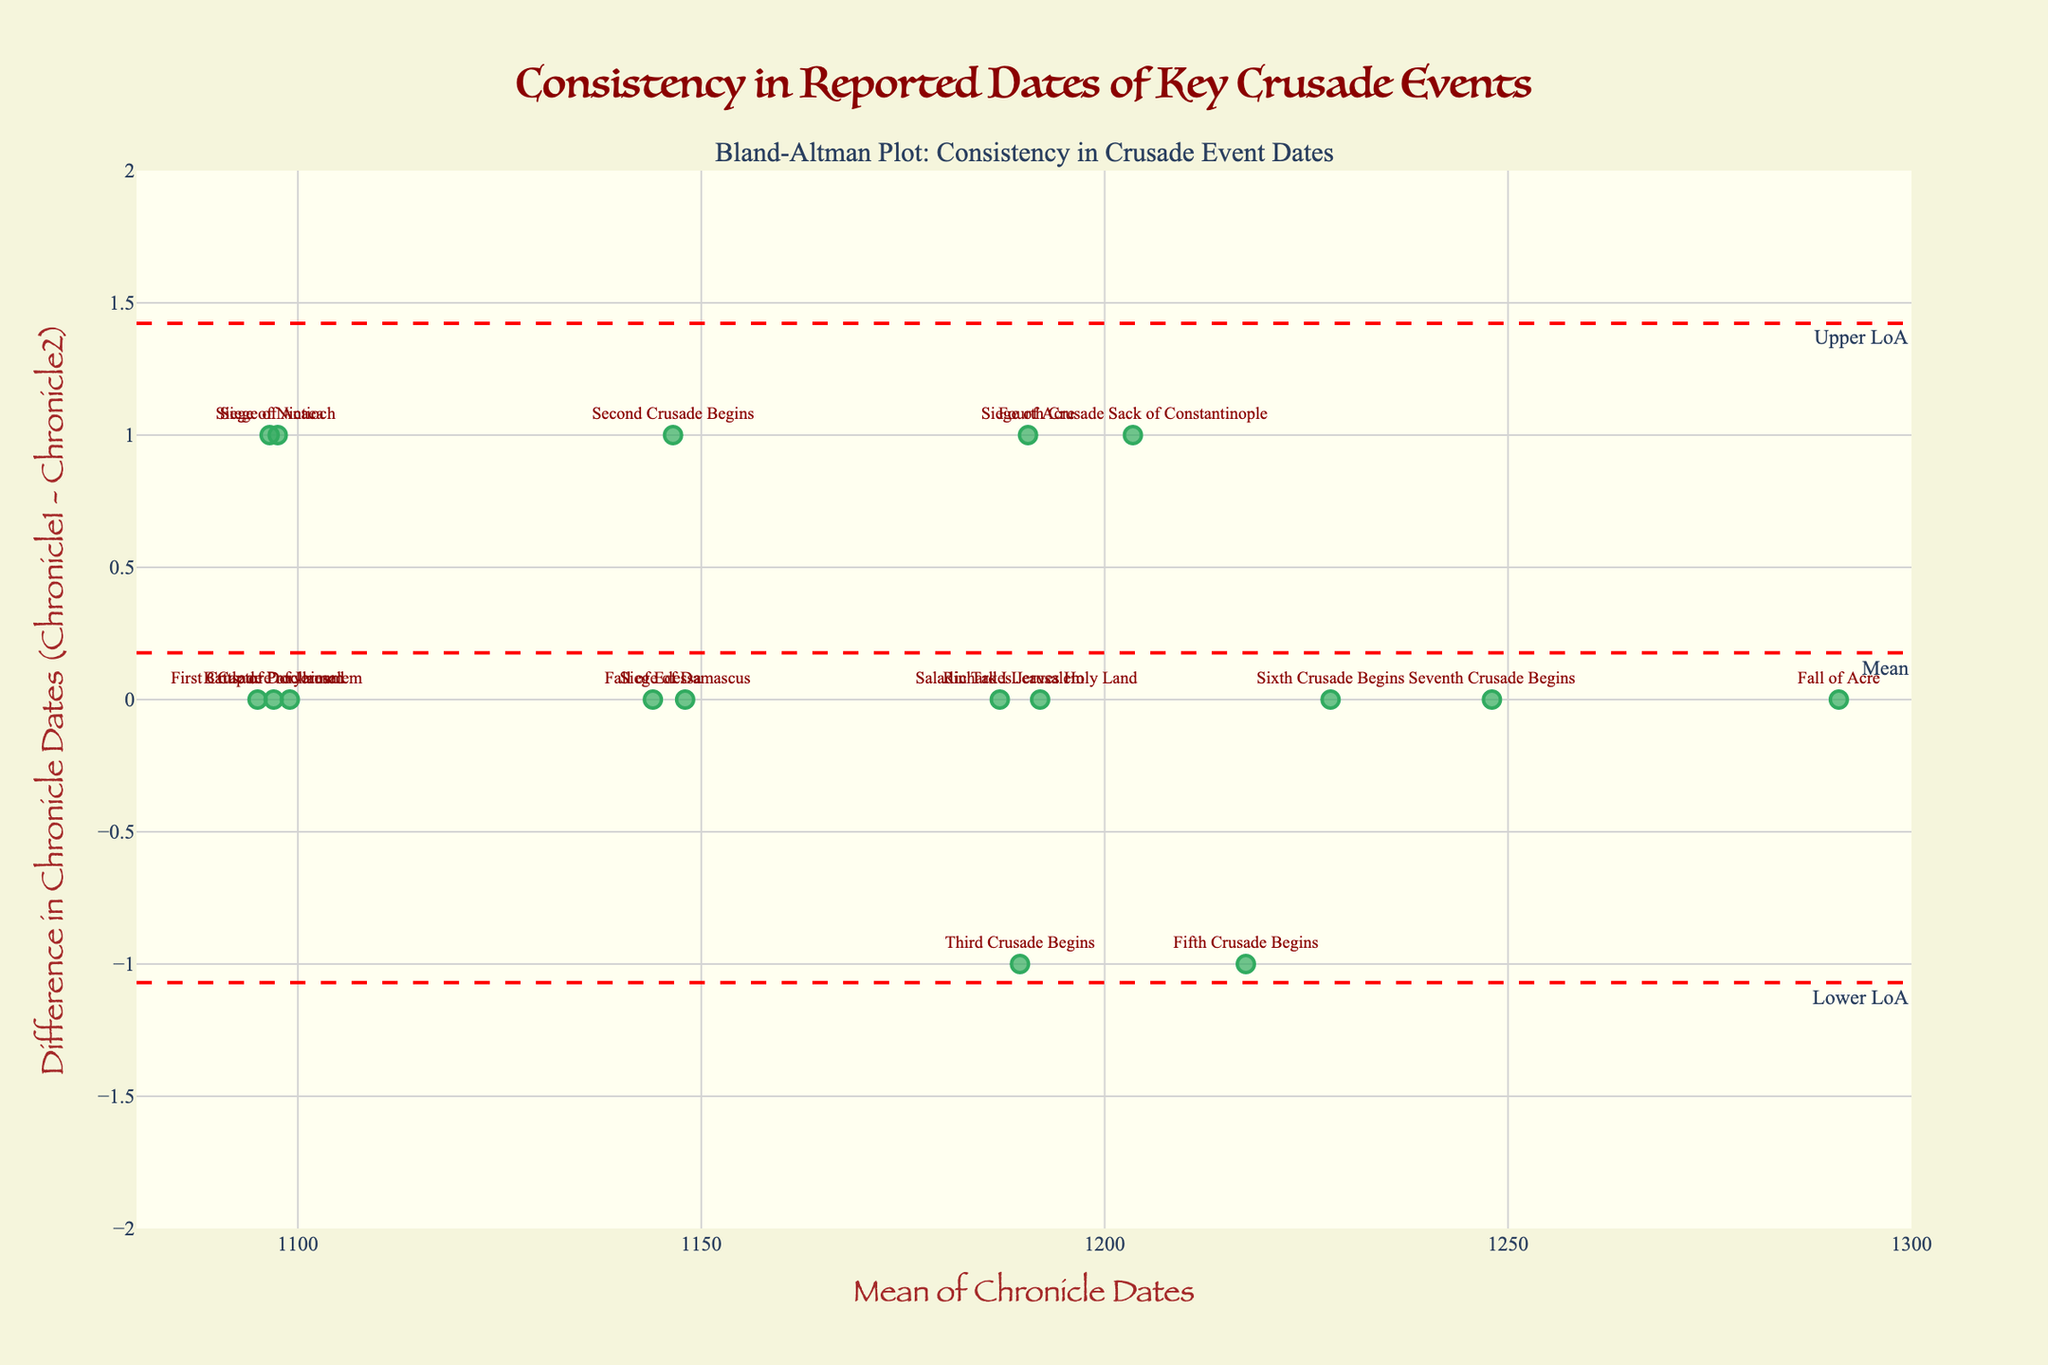What is the title of the plot? The plot title is located at the top center of the figure. It reads "Consistency in Reported Dates of Key Crusade Events".
Answer: Consistency in Reported Dates of Key Crusade Events How many events are shown in the plot? By counting the number of markers in the scatter plot, each representing a Crusade event, we find 17 events.
Answer: 17 What is the x-axis label? The x-axis label is positioned below the x-axis and reads "Mean of Chronicle Dates".
Answer: Mean of Chronicle Dates What does the horizontal dashed red line at y=0 represent? The horizontal dashed red line labeled "Mean" represents the mean difference between the dates reported in Chronicle1 and Chronicle2.
Answer: Mean difference What are the upper and lower limits of agreement? The upper and lower limits of agreement are represented by the dashed red lines labeled "Upper LoA" and "Lower LoA". They appear approximately at y=1 and y=-1, respectively.
Answer: 1 and -1 Which event has the largest positive difference between its reported dates? By examining the markers above the mean line, "Fourth Crusade Sack of Constantinople" has the largest positive difference, appearing near the upper limit of agreement.
Answer: Fourth Crusade Sack of Constantinople Which chronicle generally reports later dates for the events? Events that are above the mean difference line indicate that Chronicle1 reports later dates than Chronicle2. Multiple events above the line suggest that Chronicle1 generally reports later dates.
Answer: Chronicle1 What can be inferred about the accuracy of the chronicle dates for the event "First Crusade Proclaimed"? The point for "First Crusade Proclaimed" is exactly on the mean difference line with a difference of zero, indicating perfect agreement between the chronicles.
Answer: Perfect agreement How many events have a difference between their reported dates that fall within the limits of agreement? All events except for "Siege of Nicaea" and "Fourth Crusade Sack of Constantinople" appear to fall between the limits of -1 and 1, respectively.
Answer: 15 What does it suggest if the majority of the event differences are near zero? If most events have differences near zero, it suggests high consistency between the reported dates in both chronicle sources. The clustering of differences around zero supports this conclusion.
Answer: High consistency 